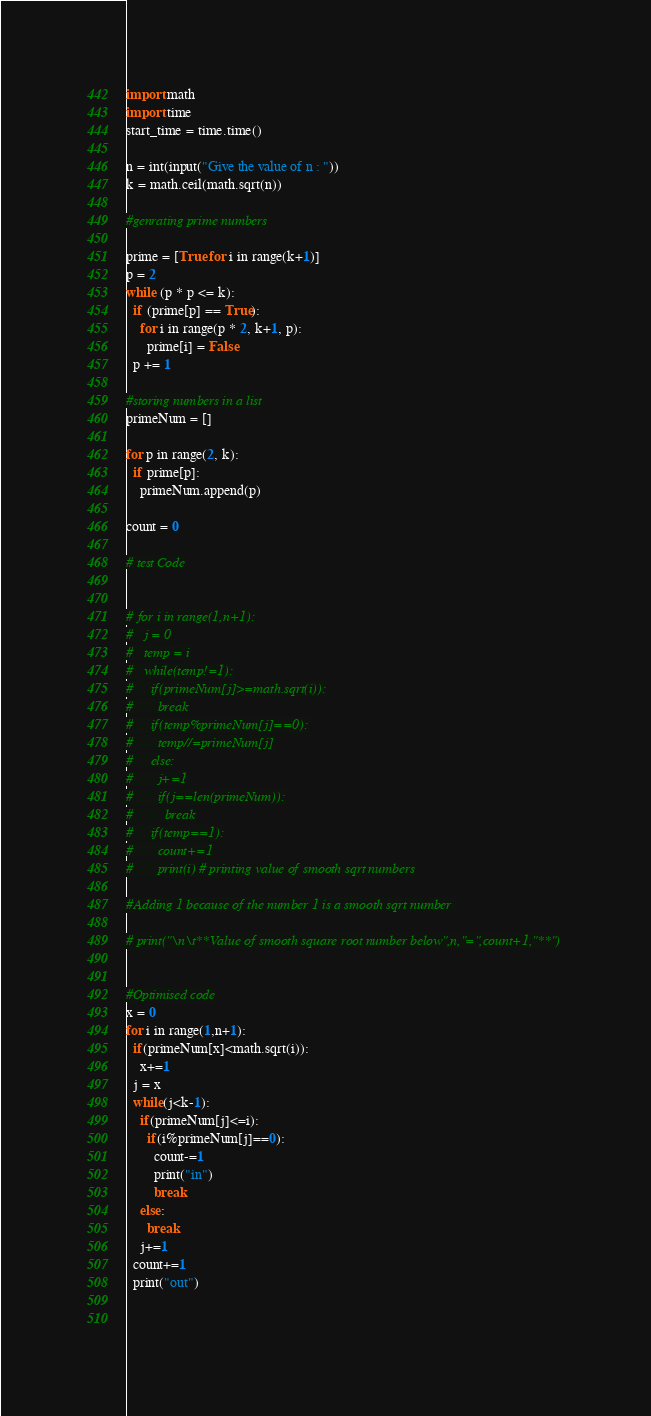<code> <loc_0><loc_0><loc_500><loc_500><_Python_>import math
import time
start_time = time.time()

n = int(input("Give the value of n : "))
k = math.ceil(math.sqrt(n))

#genrating prime numbers

prime = [True for i in range(k+1)] 
p = 2
while (p * p <= k): 
  if (prime[p] == True):
    for i in range(p * 2, k+1, p): 
      prime[i] = False
  p += 1

#storing numbers in a list
primeNum = []

for p in range(2, k): 
  if prime[p]: 
    primeNum.append(p)

count = 0

# test Code


# for i in range(1,n+1):
#   j = 0
#   temp = i
#   while(temp!=1):
#     if(primeNum[j]>=math.sqrt(i)):
#       break
#     if(temp%primeNum[j]==0):
#       temp//=primeNum[j]
#     else:
#       j+=1
#       if(j==len(primeNum)):
#         break
#     if(temp==1):
#       count+=1
#       print(i) # printing value of smooth sqrt numbers

#Adding 1 because of the number 1 is a smooth sqrt number 

# print("\n\t**Value of smooth square root number below",n,"=",count+1,"**")


#Optimised code
x = 0
for i in range(1,n+1):
  if(primeNum[x]<math.sqrt(i)):
    x+=1
  j = x
  while(j<k-1):
    if(primeNum[j]<=i):
      if(i%primeNum[j]==0):
        count-=1
        print("in")
        break
    else:
      break
    j+=1
  count+=1
  print("out")

  </code> 